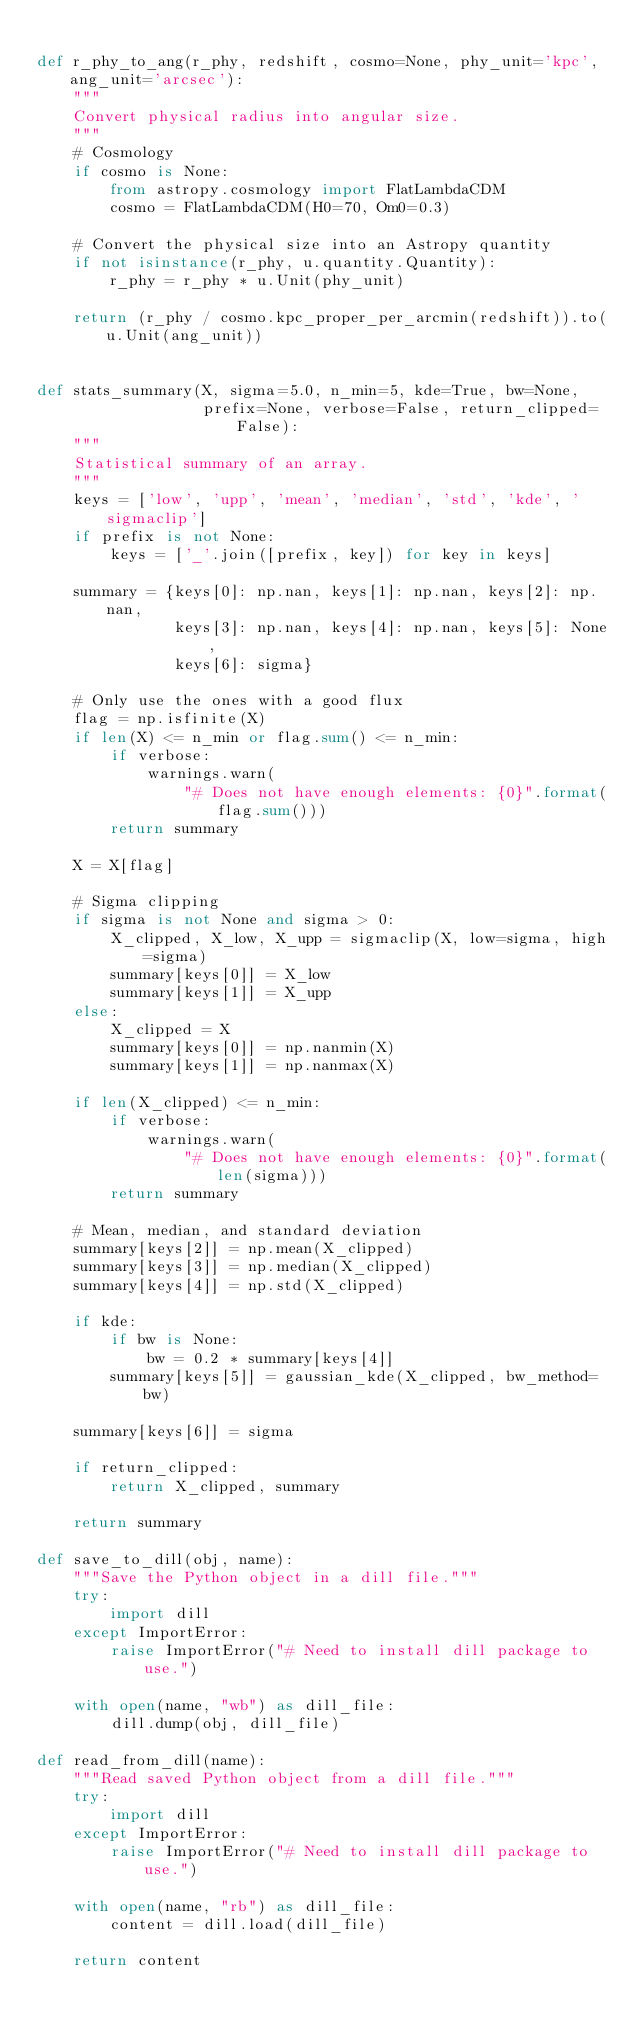<code> <loc_0><loc_0><loc_500><loc_500><_Python_>
def r_phy_to_ang(r_phy, redshift, cosmo=None, phy_unit='kpc', ang_unit='arcsec'):
    """
    Convert physical radius into angular size.
    """
    # Cosmology
    if cosmo is None:
        from astropy.cosmology import FlatLambdaCDM
        cosmo = FlatLambdaCDM(H0=70, Om0=0.3)

    # Convert the physical size into an Astropy quantity
    if not isinstance(r_phy, u.quantity.Quantity):
        r_phy = r_phy * u.Unit(phy_unit)

    return (r_phy / cosmo.kpc_proper_per_arcmin(redshift)).to(u.Unit(ang_unit))


def stats_summary(X, sigma=5.0, n_min=5, kde=True, bw=None,
                  prefix=None, verbose=False, return_clipped=False):
    """
    Statistical summary of an array.
    """
    keys = ['low', 'upp', 'mean', 'median', 'std', 'kde', 'sigmaclip']
    if prefix is not None:
        keys = ['_'.join([prefix, key]) for key in keys]

    summary = {keys[0]: np.nan, keys[1]: np.nan, keys[2]: np.nan,
               keys[3]: np.nan, keys[4]: np.nan, keys[5]: None,
               keys[6]: sigma}

    # Only use the ones with a good flux
    flag = np.isfinite(X)
    if len(X) <= n_min or flag.sum() <= n_min:
        if verbose:
            warnings.warn(
                "# Does not have enough elements: {0}".format(flag.sum()))
        return summary

    X = X[flag]

    # Sigma clipping
    if sigma is not None and sigma > 0:
        X_clipped, X_low, X_upp = sigmaclip(X, low=sigma, high=sigma)
        summary[keys[0]] = X_low
        summary[keys[1]] = X_upp
    else:
        X_clipped = X
        summary[keys[0]] = np.nanmin(X)
        summary[keys[1]] = np.nanmax(X)

    if len(X_clipped) <= n_min:
        if verbose:
            warnings.warn(
                "# Does not have enough elements: {0}".format(len(sigma)))
        return summary

    # Mean, median, and standard deviation
    summary[keys[2]] = np.mean(X_clipped)
    summary[keys[3]] = np.median(X_clipped)
    summary[keys[4]] = np.std(X_clipped)

    if kde:
        if bw is None:
            bw = 0.2 * summary[keys[4]]
        summary[keys[5]] = gaussian_kde(X_clipped, bw_method=bw)

    summary[keys[6]] = sigma

    if return_clipped:
        return X_clipped, summary

    return summary

def save_to_dill(obj, name):
    """Save the Python object in a dill file."""
    try:
        import dill
    except ImportError:
        raise ImportError("# Need to install dill package to use.")

    with open(name, "wb") as dill_file:
        dill.dump(obj, dill_file)

def read_from_dill(name):
    """Read saved Python object from a dill file."""
    try:
        import dill
    except ImportError:
        raise ImportError("# Need to install dill package to use.")

    with open(name, "rb") as dill_file:
        content = dill.load(dill_file)

    return content
</code> 